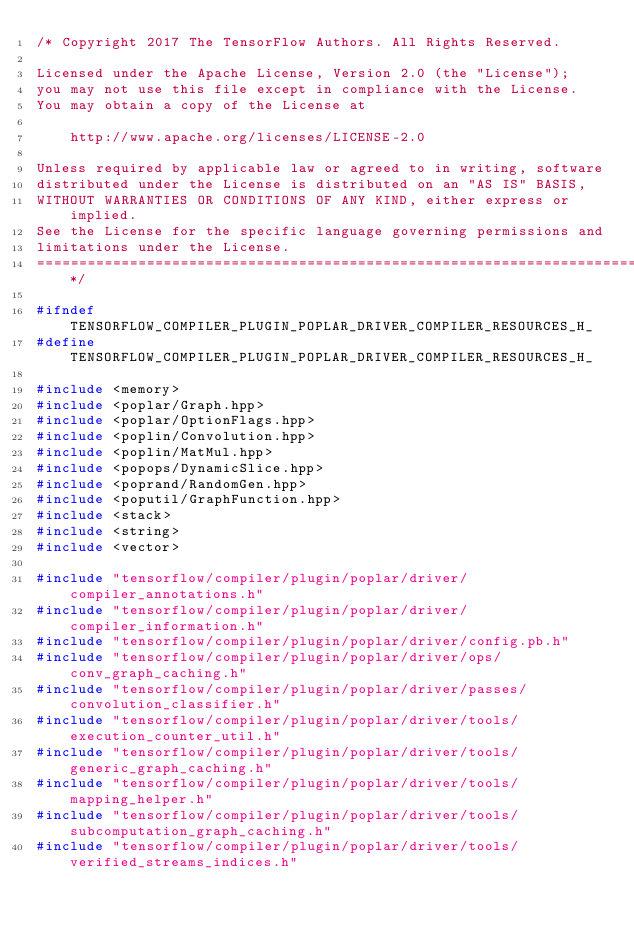Convert code to text. <code><loc_0><loc_0><loc_500><loc_500><_C_>/* Copyright 2017 The TensorFlow Authors. All Rights Reserved.

Licensed under the Apache License, Version 2.0 (the "License");
you may not use this file except in compliance with the License.
You may obtain a copy of the License at

    http://www.apache.org/licenses/LICENSE-2.0

Unless required by applicable law or agreed to in writing, software
distributed under the License is distributed on an "AS IS" BASIS,
WITHOUT WARRANTIES OR CONDITIONS OF ANY KIND, either express or implied.
See the License for the specific language governing permissions and
limitations under the License.
==============================================================================*/

#ifndef TENSORFLOW_COMPILER_PLUGIN_POPLAR_DRIVER_COMPILER_RESOURCES_H_
#define TENSORFLOW_COMPILER_PLUGIN_POPLAR_DRIVER_COMPILER_RESOURCES_H_

#include <memory>
#include <poplar/Graph.hpp>
#include <poplar/OptionFlags.hpp>
#include <poplin/Convolution.hpp>
#include <poplin/MatMul.hpp>
#include <popops/DynamicSlice.hpp>
#include <poprand/RandomGen.hpp>
#include <poputil/GraphFunction.hpp>
#include <stack>
#include <string>
#include <vector>

#include "tensorflow/compiler/plugin/poplar/driver/compiler_annotations.h"
#include "tensorflow/compiler/plugin/poplar/driver/compiler_information.h"
#include "tensorflow/compiler/plugin/poplar/driver/config.pb.h"
#include "tensorflow/compiler/plugin/poplar/driver/ops/conv_graph_caching.h"
#include "tensorflow/compiler/plugin/poplar/driver/passes/convolution_classifier.h"
#include "tensorflow/compiler/plugin/poplar/driver/tools/execution_counter_util.h"
#include "tensorflow/compiler/plugin/poplar/driver/tools/generic_graph_caching.h"
#include "tensorflow/compiler/plugin/poplar/driver/tools/mapping_helper.h"
#include "tensorflow/compiler/plugin/poplar/driver/tools/subcomputation_graph_caching.h"
#include "tensorflow/compiler/plugin/poplar/driver/tools/verified_streams_indices.h"</code> 